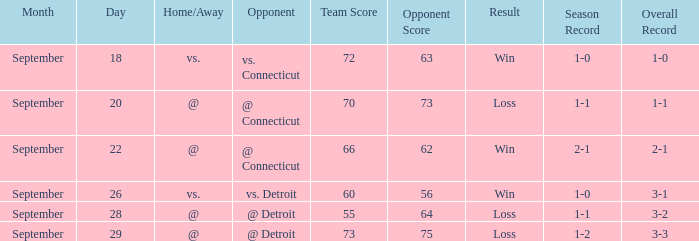What is the date with score of 66-62? September 22. 